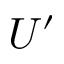<formula> <loc_0><loc_0><loc_500><loc_500>U ^ { \prime }</formula> 